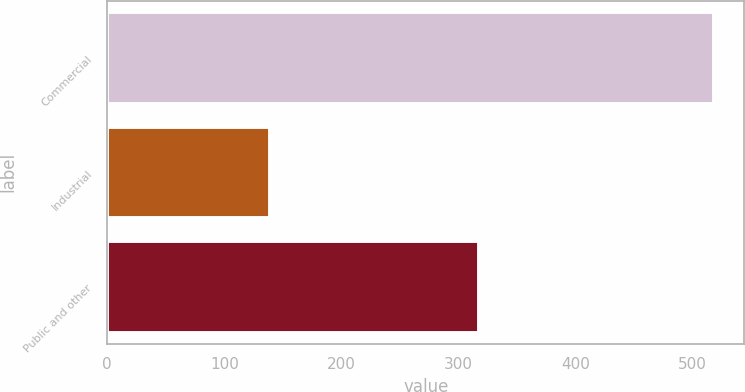Convert chart to OTSL. <chart><loc_0><loc_0><loc_500><loc_500><bar_chart><fcel>Commercial<fcel>Industrial<fcel>Public and other<nl><fcel>518.3<fcel>139.1<fcel>317.7<nl></chart> 